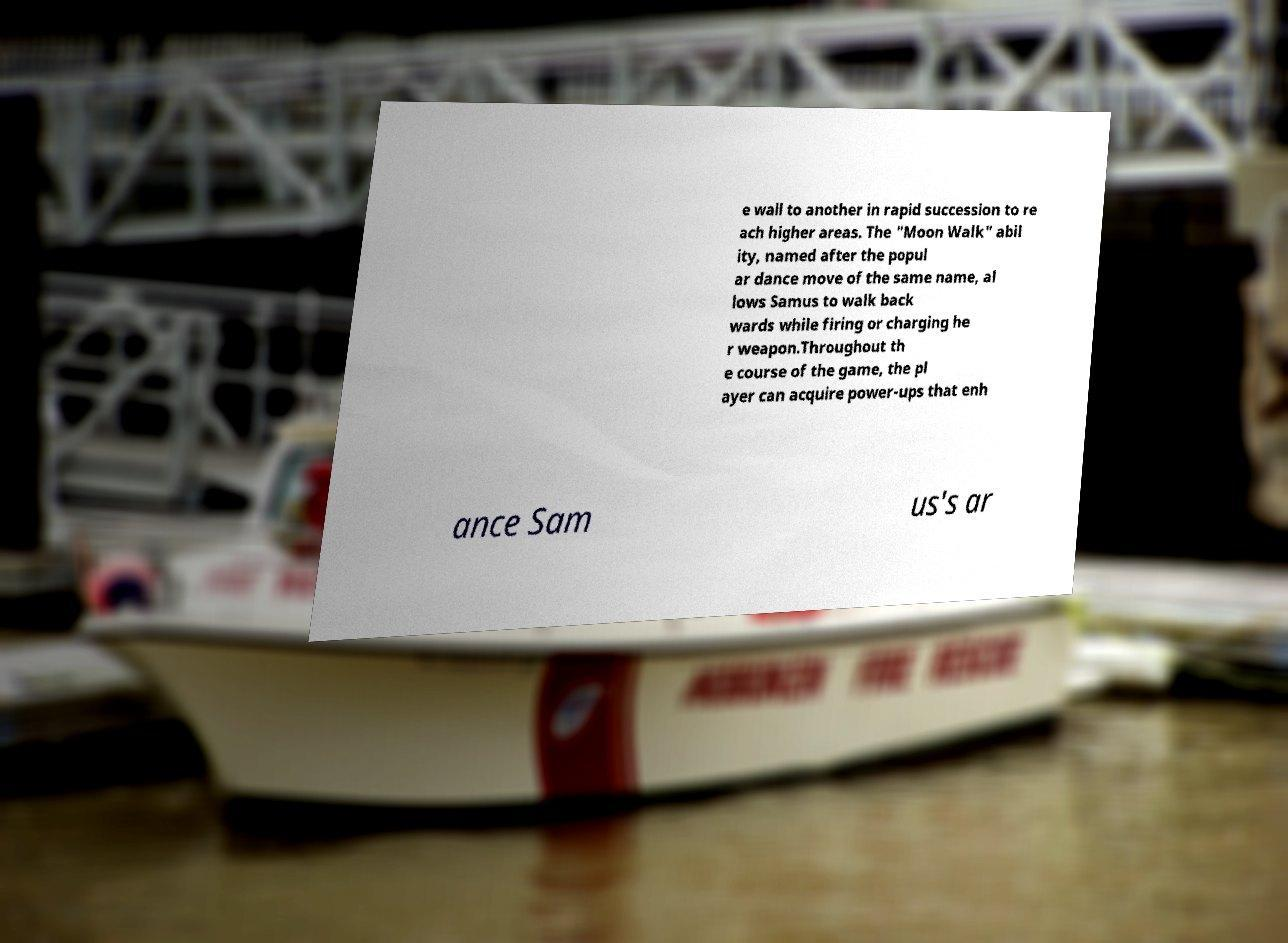Can you accurately transcribe the text from the provided image for me? e wall to another in rapid succession to re ach higher areas. The "Moon Walk" abil ity, named after the popul ar dance move of the same name, al lows Samus to walk back wards while firing or charging he r weapon.Throughout th e course of the game, the pl ayer can acquire power-ups that enh ance Sam us's ar 